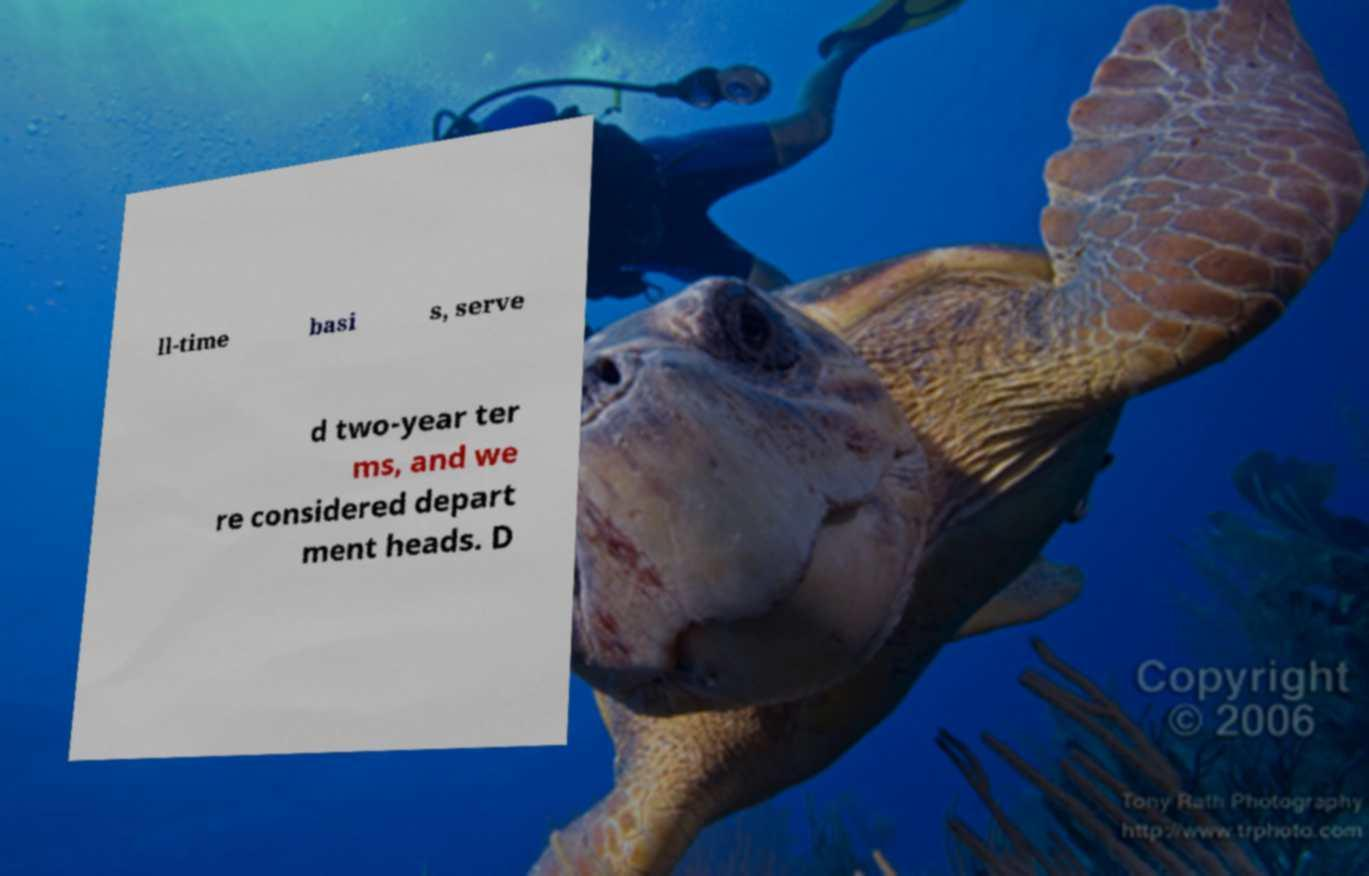There's text embedded in this image that I need extracted. Can you transcribe it verbatim? ll-time basi s, serve d two-year ter ms, and we re considered depart ment heads. D 